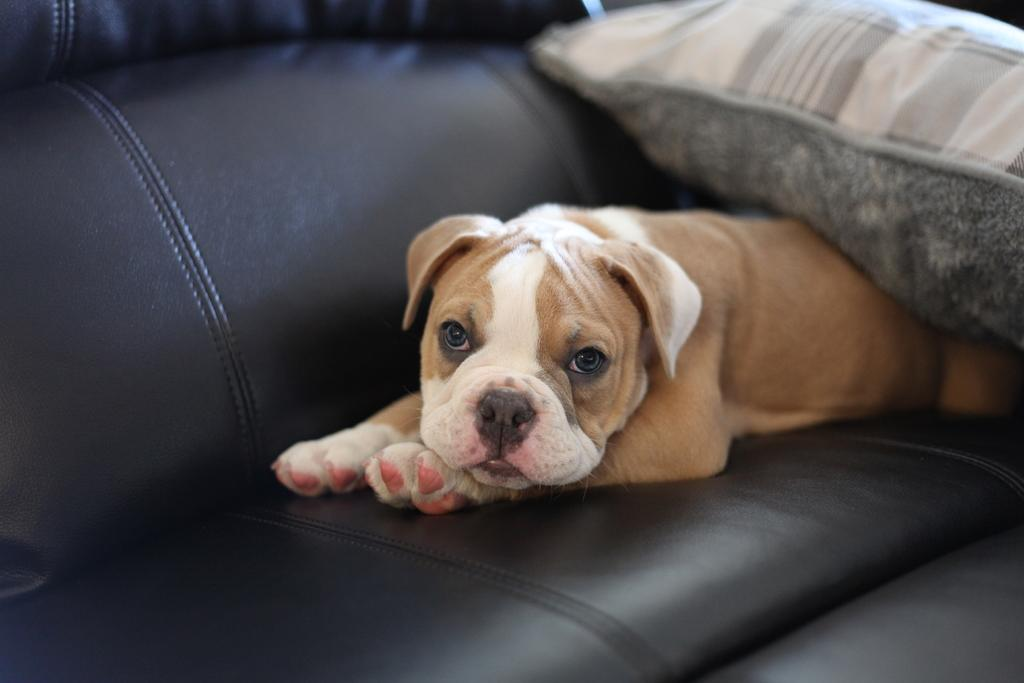What animal can be seen in the image? There is a dog in the image. Where is the dog located? The dog is on a couch. What additional object is present in the image? There is a pillow in the image. What type of yoke can be seen on the dog in the image? There is no yoke present on the dog in the image. How many sides does the square pillow have in the image? The pillow in the image is not described as a square, so we cannot determine the number of sides it has. 